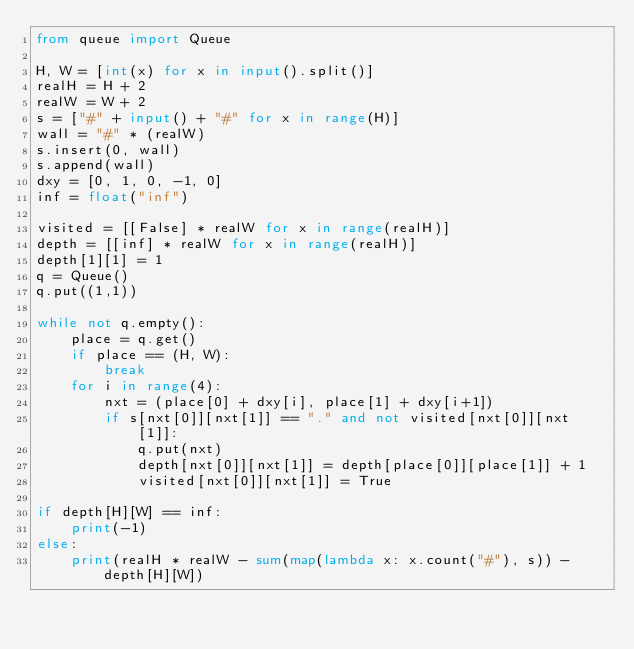<code> <loc_0><loc_0><loc_500><loc_500><_Python_>from queue import Queue

H, W = [int(x) for x in input().split()]
realH = H + 2
realW = W + 2
s = ["#" + input() + "#" for x in range(H)]
wall = "#" * (realW)
s.insert(0, wall)
s.append(wall)
dxy = [0, 1, 0, -1, 0]
inf = float("inf")

visited = [[False] * realW for x in range(realH)]
depth = [[inf] * realW for x in range(realH)]
depth[1][1] = 1
q = Queue()
q.put((1,1))

while not q.empty():
    place = q.get()
    if place == (H, W):
        break
    for i in range(4):
        nxt = (place[0] + dxy[i], place[1] + dxy[i+1])
        if s[nxt[0]][nxt[1]] == "." and not visited[nxt[0]][nxt[1]]:
            q.put(nxt)
            depth[nxt[0]][nxt[1]] = depth[place[0]][place[1]] + 1
            visited[nxt[0]][nxt[1]] = True

if depth[H][W] == inf:
    print(-1)
else:
    print(realH * realW - sum(map(lambda x: x.count("#"), s)) - depth[H][W])

</code> 